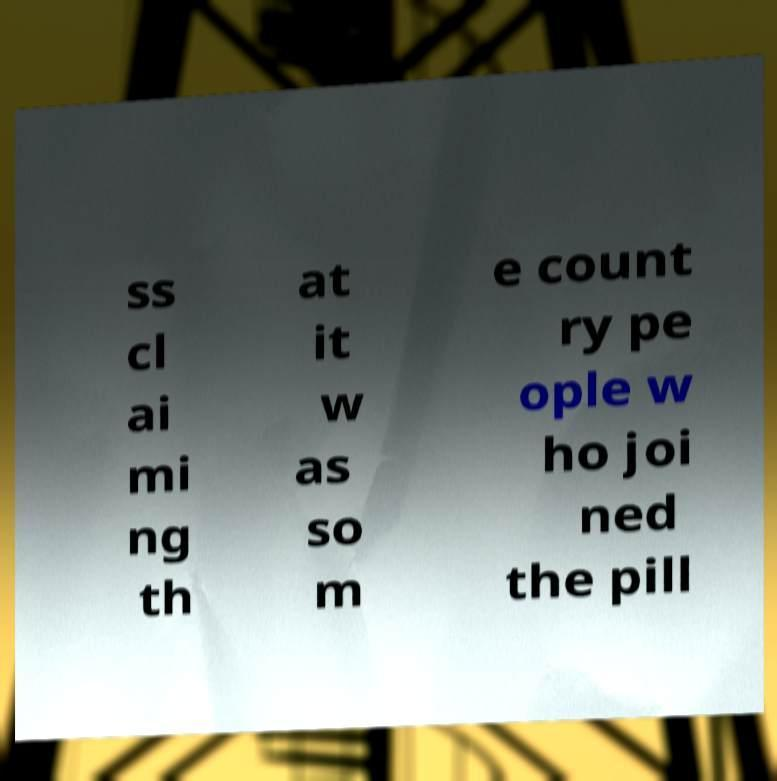Can you read and provide the text displayed in the image?This photo seems to have some interesting text. Can you extract and type it out for me? ss cl ai mi ng th at it w as so m e count ry pe ople w ho joi ned the pill 